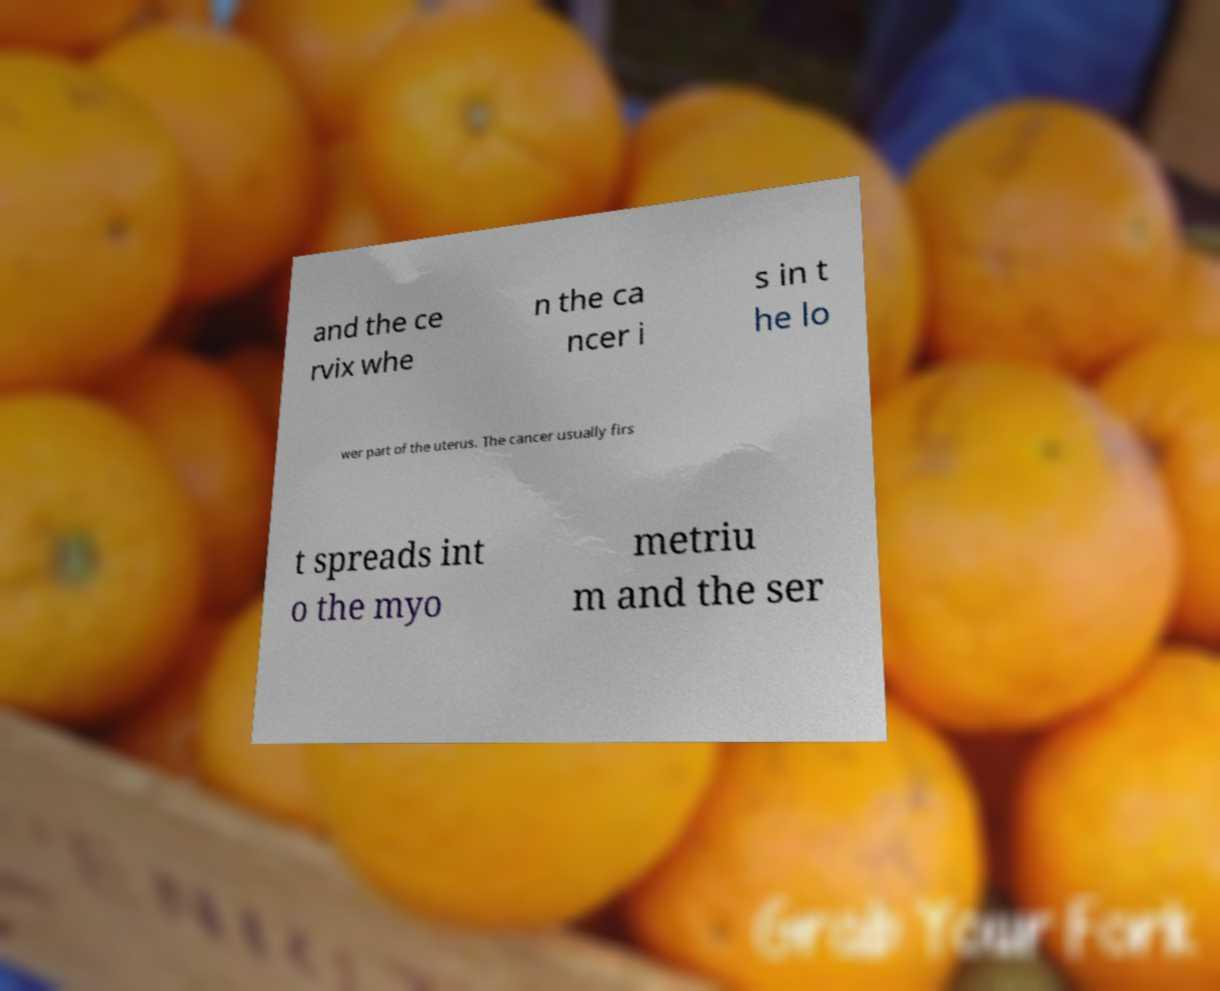I need the written content from this picture converted into text. Can you do that? and the ce rvix whe n the ca ncer i s in t he lo wer part of the uterus. The cancer usually firs t spreads int o the myo metriu m and the ser 